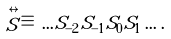<formula> <loc_0><loc_0><loc_500><loc_500>\stackrel { \leftrightarrow } { S } \, \equiv \, \dots S _ { - 2 } S _ { - 1 } S _ { 0 } S _ { 1 } \dots \, .</formula> 